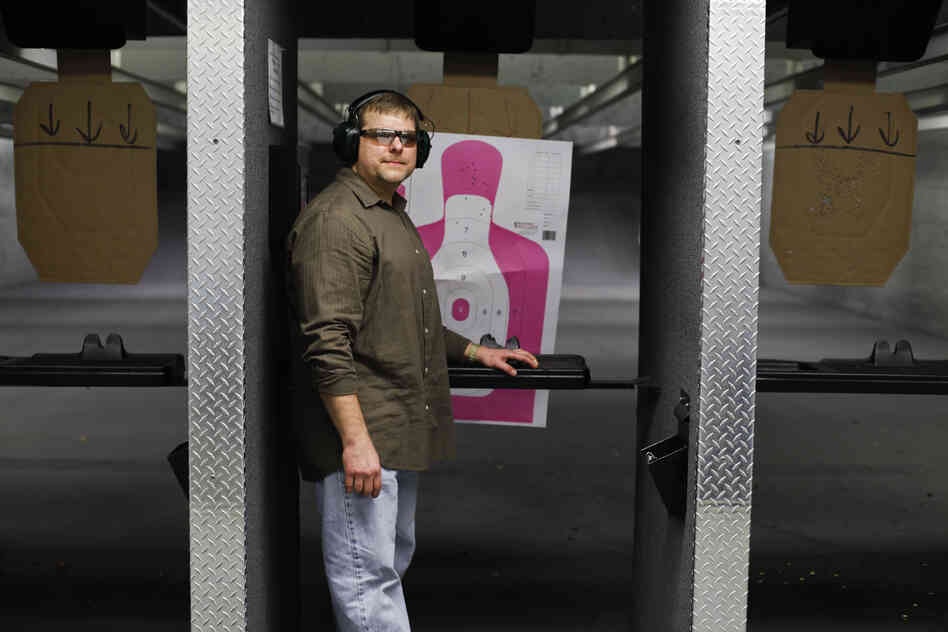Describe the setup of the shooting range and how it ensures safety and skill development. The shooting range setup is meticulously designed to ensure both safety and skill development. Each booth is separated by sturdy dividers, preventing any crossfire and maintaining a controlled shooting environment. The flat surface within each booth allows shooters to rest their equipment securely, reducing the risk of accidental discharge.

Safety is further enforced through mandatory protective gear, as seen by the man wearing ear muffs and safety glasses. The presence of different types of targets, including a human silhouette with various colored zones and another with black symbols, caters to shooters of different skill levels. Novices can use the large zones for practicing basic accuracy, while experienced shooters can challenge themselves with smaller, more precise areas. Overall, the range's layout and equipment foster a safe and skill-enhancing environment for all users. What kind of advanced training exercises might be conducted at this range? Advanced training exercises at this shooting range could include precision targeting, timed drills, and tactical movement practices. Precision targeting exercises would focus on hitting smaller target zones or specific areas on the silhouette, honing accuracy and control. Timed drills might involve shooting a sequence of targets within a set period, improving speed and reflexes.

Tactical movement practices could include transitioning between different shooting positions or moving between barriers, simulating real-life scenarios. Shooters might also engage in scenario-based training, where they respond to hypothetical threats or situations. These exercises challenge experienced shooters, helping them refine their skills under varied and dynamic conditions. 